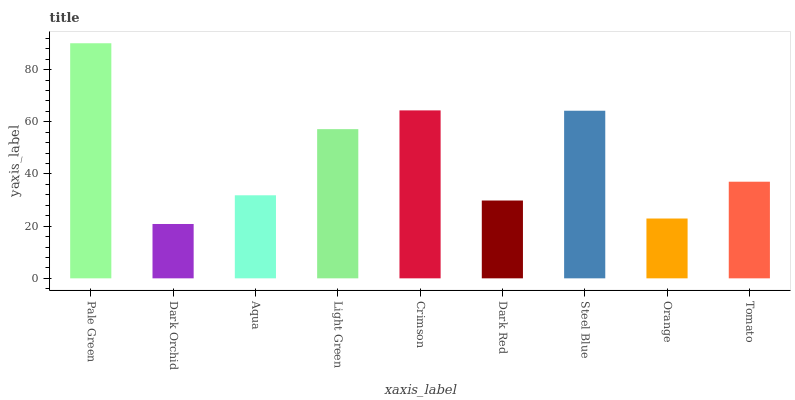Is Dark Orchid the minimum?
Answer yes or no. Yes. Is Pale Green the maximum?
Answer yes or no. Yes. Is Aqua the minimum?
Answer yes or no. No. Is Aqua the maximum?
Answer yes or no. No. Is Aqua greater than Dark Orchid?
Answer yes or no. Yes. Is Dark Orchid less than Aqua?
Answer yes or no. Yes. Is Dark Orchid greater than Aqua?
Answer yes or no. No. Is Aqua less than Dark Orchid?
Answer yes or no. No. Is Tomato the high median?
Answer yes or no. Yes. Is Tomato the low median?
Answer yes or no. Yes. Is Aqua the high median?
Answer yes or no. No. Is Light Green the low median?
Answer yes or no. No. 